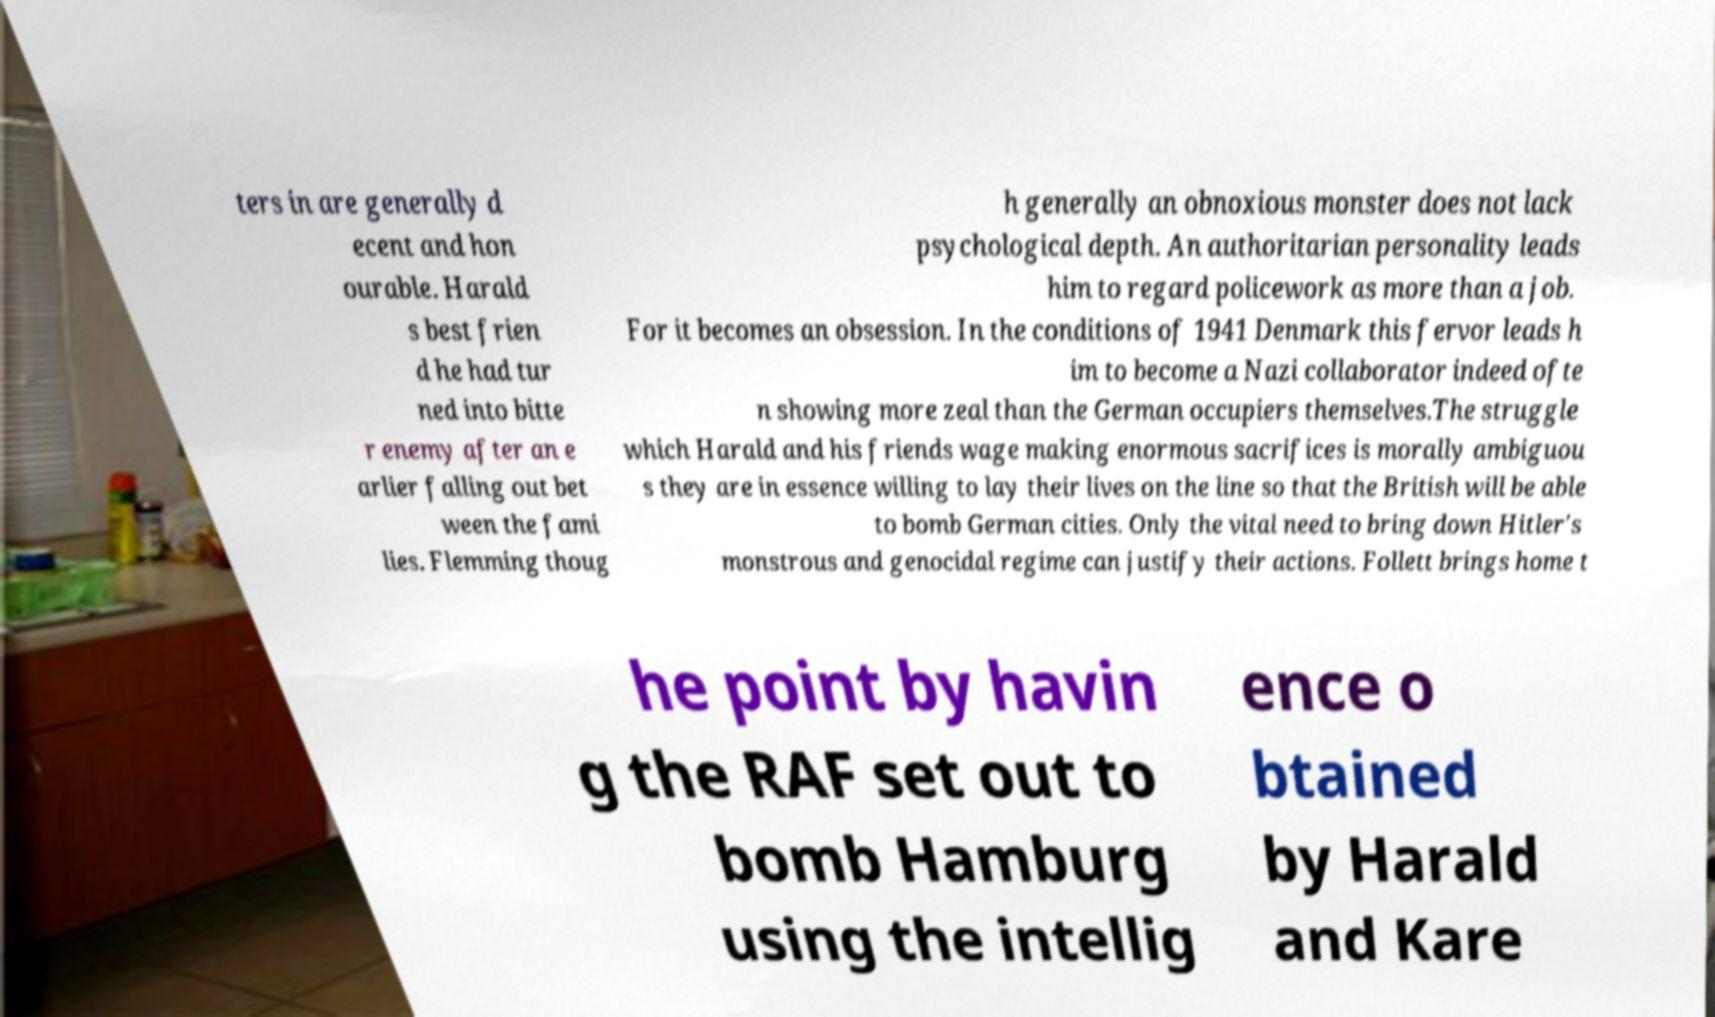Can you read and provide the text displayed in the image?This photo seems to have some interesting text. Can you extract and type it out for me? ters in are generally d ecent and hon ourable. Harald s best frien d he had tur ned into bitte r enemy after an e arlier falling out bet ween the fami lies. Flemming thoug h generally an obnoxious monster does not lack psychological depth. An authoritarian personality leads him to regard policework as more than a job. For it becomes an obsession. In the conditions of 1941 Denmark this fervor leads h im to become a Nazi collaborator indeed ofte n showing more zeal than the German occupiers themselves.The struggle which Harald and his friends wage making enormous sacrifices is morally ambiguou s they are in essence willing to lay their lives on the line so that the British will be able to bomb German cities. Only the vital need to bring down Hitler's monstrous and genocidal regime can justify their actions. Follett brings home t he point by havin g the RAF set out to bomb Hamburg using the intellig ence o btained by Harald and Kare 